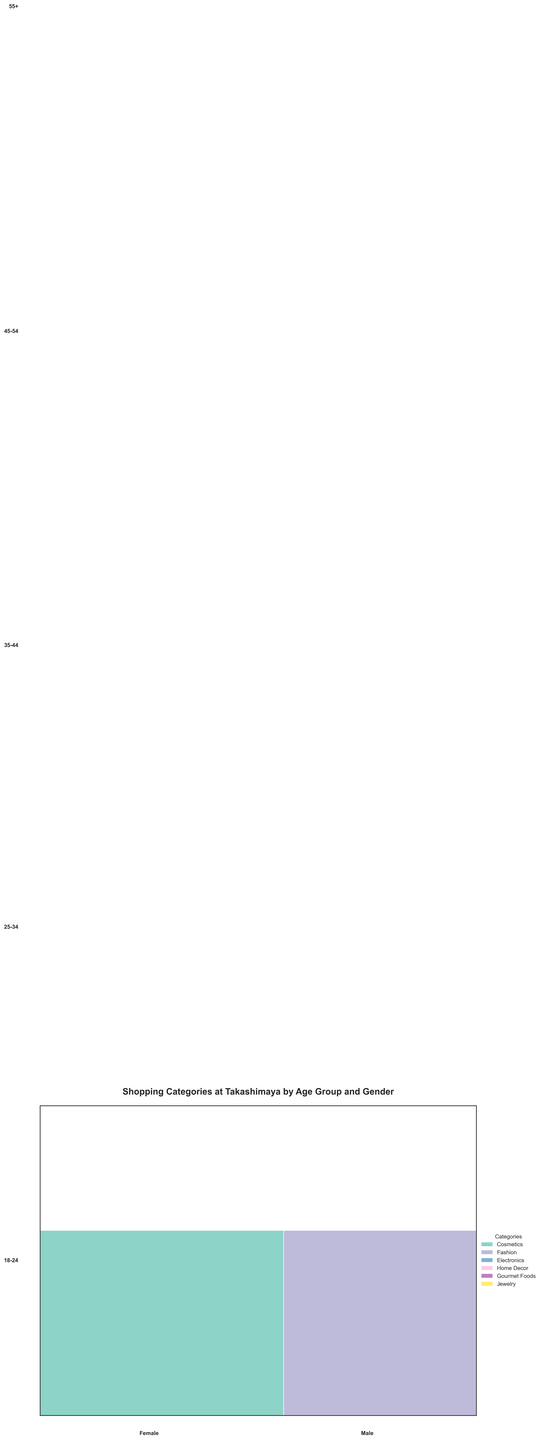What is the most popular shopping category for females aged 18-24? By looking at the segment for females aged 18-24, the largest area represents Cosmetics with a frequency of 120.
Answer: Cosmetics Which age group has the highest frequency of Fashion purchases among males? Checking the male segments across all age groups and comparing the size of the Fashion category, the age group 18-24 has the largest Fashion segment with a frequency of 65.
Answer: 18-24 How does the frequency of Jewelry purchases by females aged 45-54 compare to those aged 35-44? The segment for females aged 45-54 shows a frequency of 115 for Jewelry, while for females aged 35-44, it is 105. 115 is greater than 105.
Answer: More in 45-54 What is the total number of Electronics purchases by males across all age groups? Adding up the frequencies of Electronics for males in all age groups: 18-24 (80) + 25-34 (95) + 45-54 (80) = 255.
Answer: 255 Which category has the highest frequency for females aged 25-34? Looking at the segment for females aged 25-34, the largest area represents Fashion with a frequency of 135.
Answer: Fashion What is the combined frequency of Home Decor purchases by females aged 25-34 and 55+? Adding the Home Decor frequencies for females aged 25-34 (110) and 55+ (130): 110 + 130 = 240.
Answer: 240 In which age group do males have the highest frequency of Gourmet Foods purchases? Comparing the Gourmet Foods frequencies for males across different age groups, 55+ has the highest frequency with 110.
Answer: 55+ How does the frequency of Cosmetics purchases by females aged 18-24 compare to the frequency by females aged 45-54? The segment for females aged 18-24 shows a frequency of 120 for Cosmetics, while for females aged 45-54, it is 100. 120 is greater than 100.
Answer: More in 18-24 What is the smallest shopping category for males aged 25-34? By looking at the segment for males aged 25-34, the smallest area represents Gourmet Foods with a frequency of 75.
Answer: Gourmet Foods 